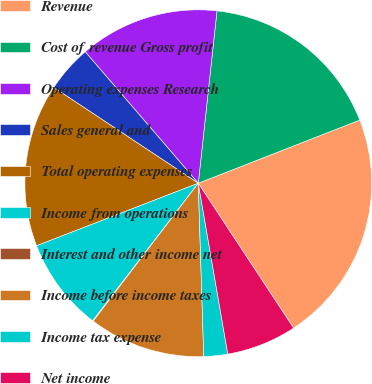Convert chart. <chart><loc_0><loc_0><loc_500><loc_500><pie_chart><fcel>Revenue<fcel>Cost of revenue Gross profit<fcel>Operating expenses Research<fcel>Sales general and<fcel>Total operating expenses<fcel>Income from operations<fcel>Interest and other income net<fcel>Income before income taxes<fcel>Income tax expense<fcel>Net income<nl><fcel>21.66%<fcel>17.34%<fcel>13.02%<fcel>4.38%<fcel>15.18%<fcel>8.7%<fcel>0.06%<fcel>10.86%<fcel>2.22%<fcel>6.54%<nl></chart> 